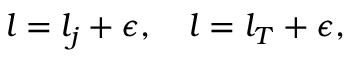<formula> <loc_0><loc_0><loc_500><loc_500>l = l _ { j } + \epsilon , \quad l = l _ { T } + \epsilon ,</formula> 